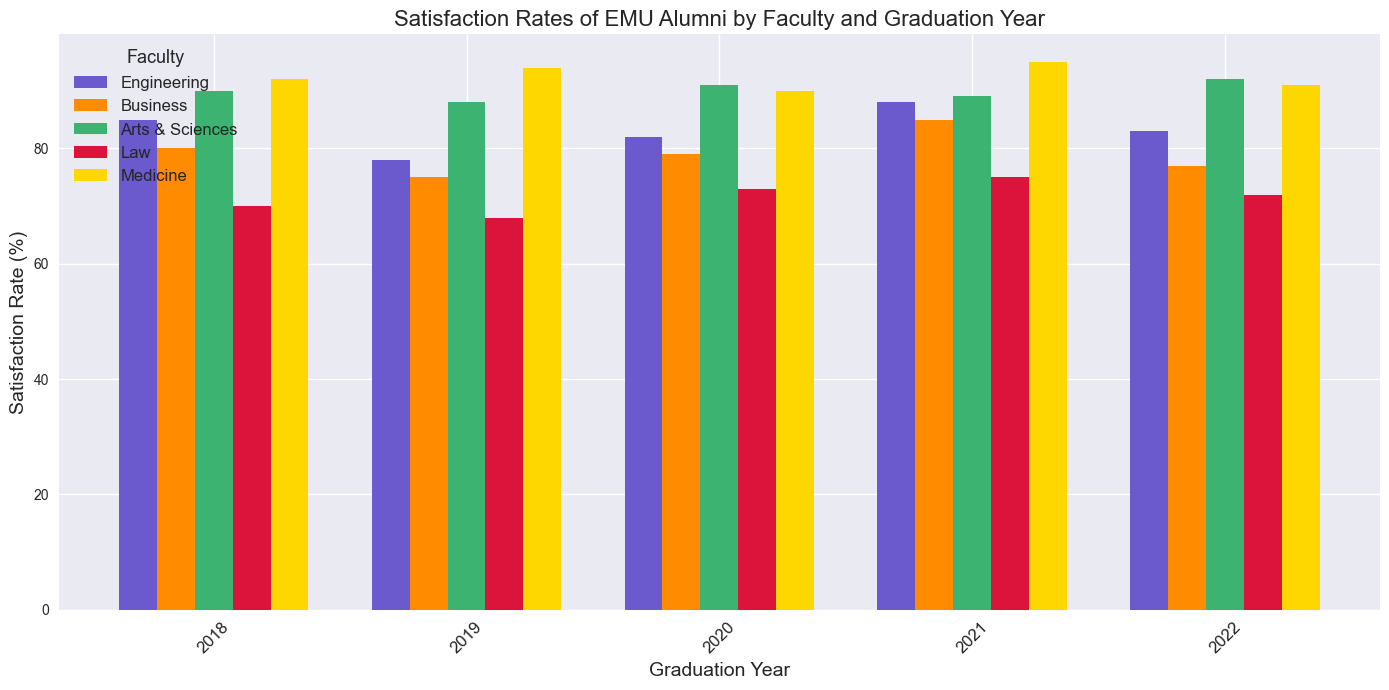What was the highest satisfaction rate for the Engineering faculty? Look at the bar heights for the Engineering faculty across the years. The highest bar represents the highest satisfaction rate. The bar for 2021 is the tallest at 88%.
Answer: 88% Which faculty had the lowest satisfaction rate in 2019? Compare the bar heights for all faculties in 2019. The Law faculty has the shortest bar with a satisfaction rate of 68%.
Answer: Law Between 2021 and 2022, how did the satisfaction rate for Business faculty change? Check the bar heights for Business faculty in 2021 and 2022. In 2021, the rate is 85%, and in 2022 it is 77%. The rate decreased.
Answer: Decreased What is the average satisfaction rate for the Medicine faculty from 2018 to 2022? Add the satisfaction rates for the Medicine faculty across the years (92, 94, 90, 95, 91) and divide by the number of years (5). (92+94+90+95+91)/5 = 92.4%.
Answer: 92.4% Which two faculties have the most similar satisfaction rates in 2020? Compare the bar heights for all faculties in 2020. Engineering and Business have close rates—82% for Engineering and 79% for Business.
Answer: Engineering and Business What is the total satisfaction rate for all faculties in 2018? Add the satisfaction rates for all faculties for the year 2018 (85 + 80 + 90 + 70 + 92). 85+80+90+70+92 = 417%.
Answer: 417% Did any faculty show a consistent increase in satisfaction rates from 2018 to 2022? Compare the bar heights for each faculty across the years to see if any have consistently increasing bars. The Medicine faculty shows a consistent but small fluctuation instead of consistent increase.
Answer: None Which faculty showed the highest satisfaction rate improvement between 2019 and 2020? Subtract the 2019 rate from the 2020 rate for all faculties. The Arts & Sciences faculty improved from 88% to 91%, a change of 3%.
Answer: Arts & Sciences In 2020, which faculty had a satisfaction rate greater than 85% but less than 95%? Look at the bar heights for 2020 and identify bars within that range. The Medicine faculty at 90% and Arts & Sciences at 91% fit the criteria.
Answer: Medicine and Arts & Sciences 